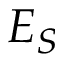Convert formula to latex. <formula><loc_0><loc_0><loc_500><loc_500>E _ { S }</formula> 